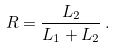Convert formula to latex. <formula><loc_0><loc_0><loc_500><loc_500>R = \frac { L _ { 2 } } { L _ { 1 } + L _ { 2 } } \, .</formula> 